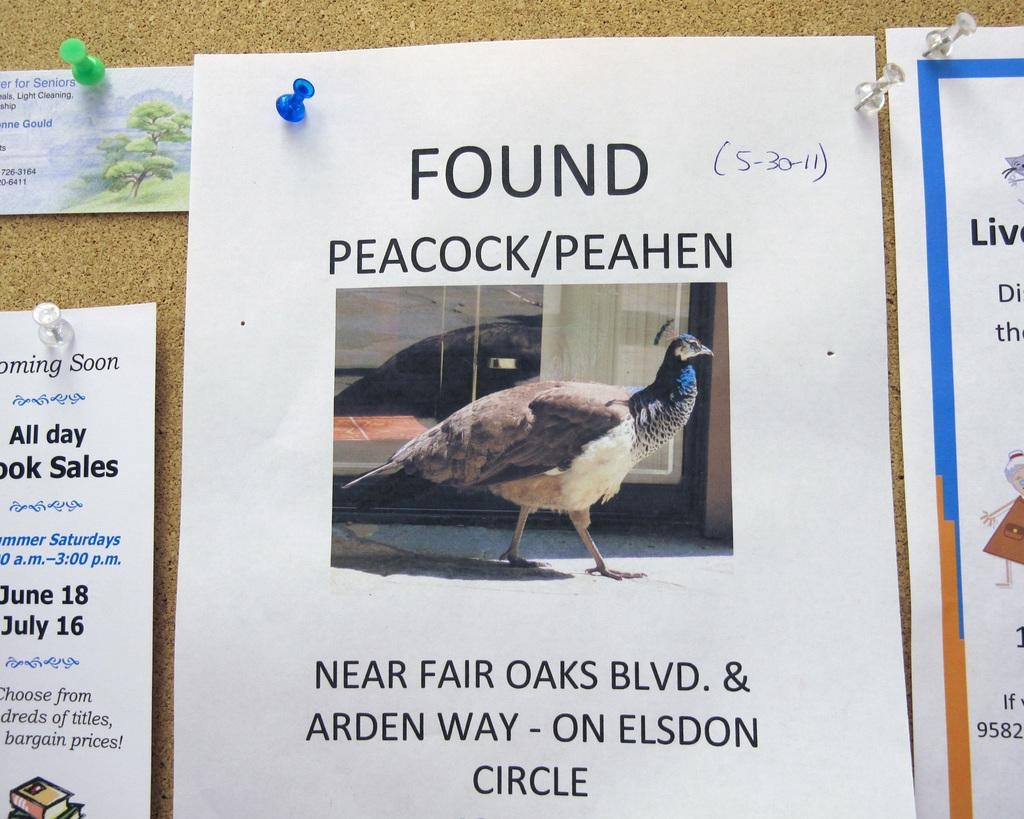What is present on the papers in the image? The papers have images and text. How are the papers arranged in the image? The papers are attached to a wall. What type of songs can be heard coming from the clam in the image? There is no clam present in the image, and therefore no songs can be heard. 